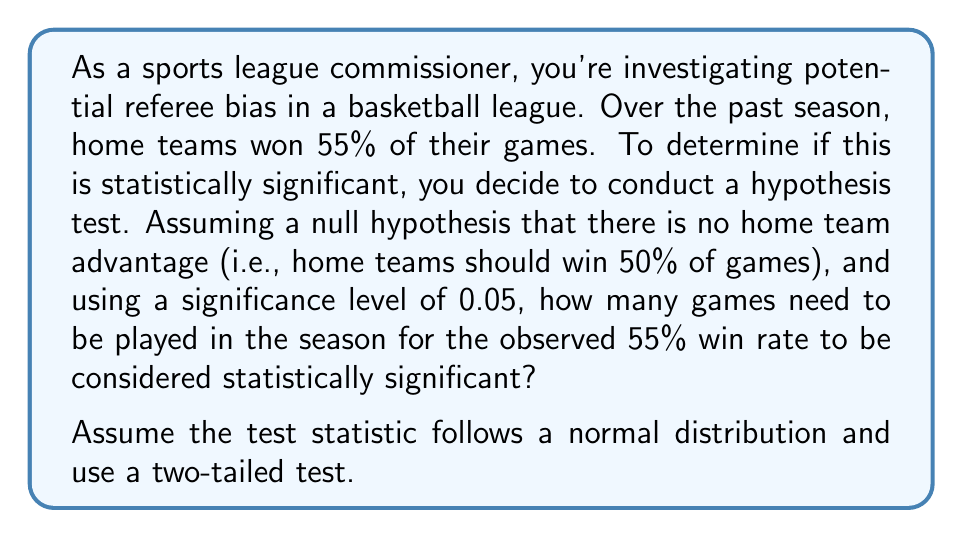Could you help me with this problem? To solve this problem, we'll use the following steps:

1) First, we need to set up our hypotheses:
   $H_0: p = 0.5$ (null hypothesis, no home advantage)
   $H_a: p \neq 0.5$ (alternative hypothesis, there is a home advantage)

2) We're using a significance level $\alpha = 0.05$ for a two-tailed test. This means we need a z-score of ±1.96 for statistical significance.

3) The formula for the z-score in this case is:

   $$z = \frac{\hat{p} - p_0}{\sqrt{\frac{p_0(1-p_0)}{n}}}$$

   Where:
   $\hat{p}$ = observed proportion (0.55)
   $p_0$ = hypothesized proportion (0.5)
   $n$ = number of games

4) We want to find $n$ when $z = 1.96$ (we use the positive z-score as $\hat{p} > p_0$):

   $$1.96 = \frac{0.55 - 0.5}{\sqrt{\frac{0.5(1-0.5)}{n}}}$$

5) Simplify the right side:

   $$1.96 = \frac{0.05}{\sqrt{\frac{0.25}{n}}}$$

6) Square both sides:

   $$3.8416 = \frac{0.0025n}{0.25}$$

7) Multiply both sides by 0.25:

   $$0.9604 = 0.0025n$$

8) Divide both sides by 0.0025:

   $$n = 384.16$$

9) Since $n$ must be a whole number, we round up to ensure the significance level is met.
Answer: 385 games 